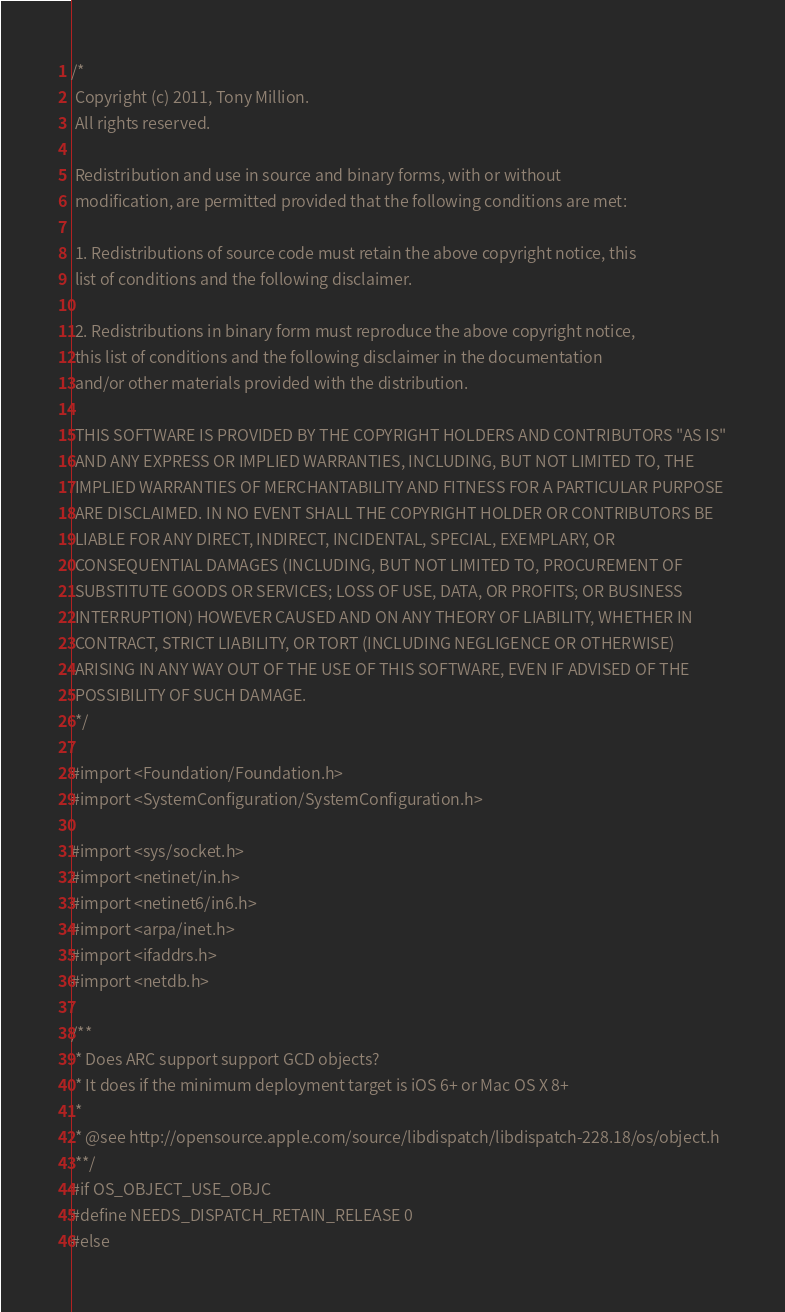Convert code to text. <code><loc_0><loc_0><loc_500><loc_500><_C_>/*
 Copyright (c) 2011, Tony Million.
 All rights reserved.
 
 Redistribution and use in source and binary forms, with or without
 modification, are permitted provided that the following conditions are met:
 
 1. Redistributions of source code must retain the above copyright notice, this
 list of conditions and the following disclaimer.
 
 2. Redistributions in binary form must reproduce the above copyright notice,
 this list of conditions and the following disclaimer in the documentation
 and/or other materials provided with the distribution.
 
 THIS SOFTWARE IS PROVIDED BY THE COPYRIGHT HOLDERS AND CONTRIBUTORS "AS IS"
 AND ANY EXPRESS OR IMPLIED WARRANTIES, INCLUDING, BUT NOT LIMITED TO, THE
 IMPLIED WARRANTIES OF MERCHANTABILITY AND FITNESS FOR A PARTICULAR PURPOSE
 ARE DISCLAIMED. IN NO EVENT SHALL THE COPYRIGHT HOLDER OR CONTRIBUTORS BE
 LIABLE FOR ANY DIRECT, INDIRECT, INCIDENTAL, SPECIAL, EXEMPLARY, OR
 CONSEQUENTIAL DAMAGES (INCLUDING, BUT NOT LIMITED TO, PROCUREMENT OF
 SUBSTITUTE GOODS OR SERVICES; LOSS OF USE, DATA, OR PROFITS; OR BUSINESS
 INTERRUPTION) HOWEVER CAUSED AND ON ANY THEORY OF LIABILITY, WHETHER IN
 CONTRACT, STRICT LIABILITY, OR TORT (INCLUDING NEGLIGENCE OR OTHERWISE)
 ARISING IN ANY WAY OUT OF THE USE OF THIS SOFTWARE, EVEN IF ADVISED OF THE
 POSSIBILITY OF SUCH DAMAGE. 
 */

#import <Foundation/Foundation.h>
#import <SystemConfiguration/SystemConfiguration.h>

#import <sys/socket.h>
#import <netinet/in.h>
#import <netinet6/in6.h>
#import <arpa/inet.h>
#import <ifaddrs.h>
#import <netdb.h>

/**
 * Does ARC support support GCD objects?
 * It does if the minimum deployment target is iOS 6+ or Mac OS X 8+
 * 
 * @see http://opensource.apple.com/source/libdispatch/libdispatch-228.18/os/object.h
 **/
#if OS_OBJECT_USE_OBJC
#define NEEDS_DISPATCH_RETAIN_RELEASE 0
#else</code> 